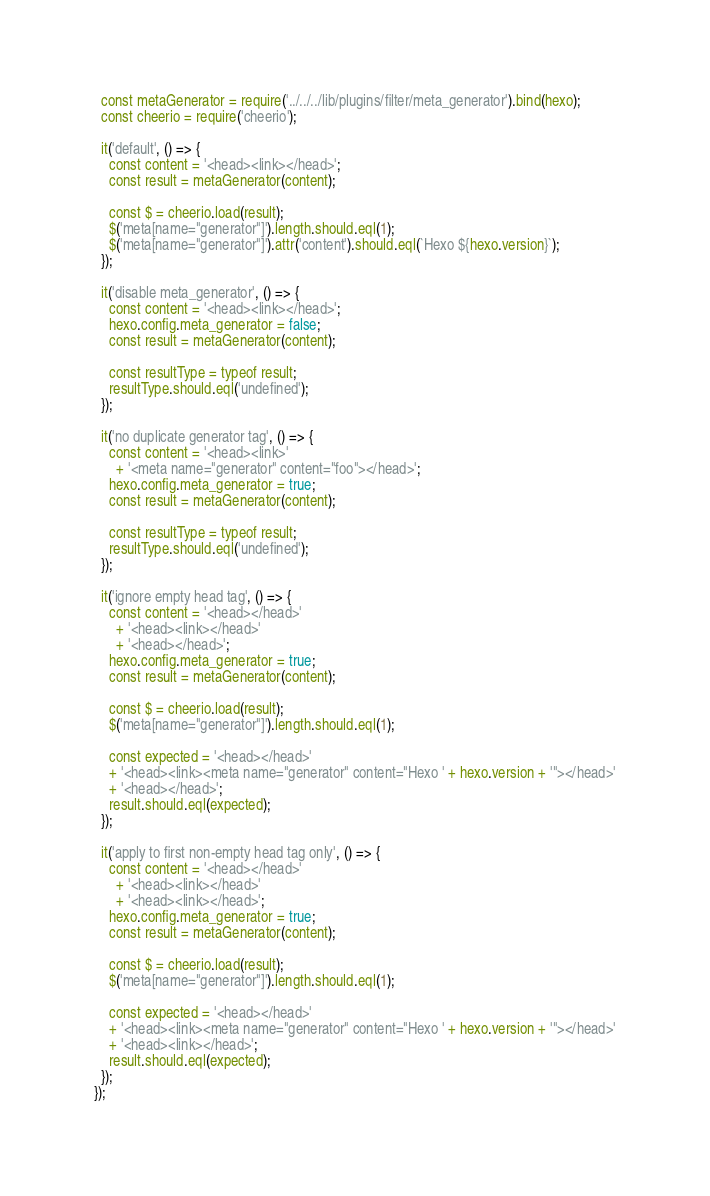<code> <loc_0><loc_0><loc_500><loc_500><_JavaScript_>  const metaGenerator = require('../../../lib/plugins/filter/meta_generator').bind(hexo);
  const cheerio = require('cheerio');

  it('default', () => {
    const content = '<head><link></head>';
    const result = metaGenerator(content);

    const $ = cheerio.load(result);
    $('meta[name="generator"]').length.should.eql(1);
    $('meta[name="generator"]').attr('content').should.eql(`Hexo ${hexo.version}`);
  });

  it('disable meta_generator', () => {
    const content = '<head><link></head>';
    hexo.config.meta_generator = false;
    const result = metaGenerator(content);

    const resultType = typeof result;
    resultType.should.eql('undefined');
  });

  it('no duplicate generator tag', () => {
    const content = '<head><link>'
      + '<meta name="generator" content="foo"></head>';
    hexo.config.meta_generator = true;
    const result = metaGenerator(content);

    const resultType = typeof result;
    resultType.should.eql('undefined');
  });

  it('ignore empty head tag', () => {
    const content = '<head></head>'
      + '<head><link></head>'
      + '<head></head>';
    hexo.config.meta_generator = true;
    const result = metaGenerator(content);

    const $ = cheerio.load(result);
    $('meta[name="generator"]').length.should.eql(1);

    const expected = '<head></head>'
    + '<head><link><meta name="generator" content="Hexo ' + hexo.version + '"></head>'
    + '<head></head>';
    result.should.eql(expected);
  });

  it('apply to first non-empty head tag only', () => {
    const content = '<head></head>'
      + '<head><link></head>'
      + '<head><link></head>';
    hexo.config.meta_generator = true;
    const result = metaGenerator(content);

    const $ = cheerio.load(result);
    $('meta[name="generator"]').length.should.eql(1);

    const expected = '<head></head>'
    + '<head><link><meta name="generator" content="Hexo ' + hexo.version + '"></head>'
    + '<head><link></head>';
    result.should.eql(expected);
  });
});
</code> 